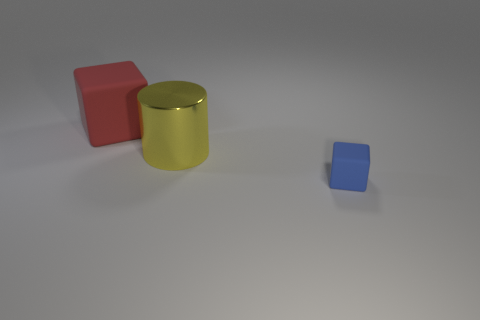What number of blue metal cylinders are there?
Make the answer very short. 0. What is the material of the large object that is on the right side of the matte cube that is behind the small matte object?
Make the answer very short. Metal. What color is the big thing in front of the block that is behind the big thing in front of the large rubber object?
Your response must be concise. Yellow. Do the big rubber cube and the metallic object have the same color?
Your answer should be very brief. No. What number of yellow things have the same size as the red matte object?
Offer a terse response. 1. Are there more metal cylinders that are in front of the small rubber cube than red matte objects behind the red matte cube?
Provide a short and direct response. No. There is a cube to the left of the matte object that is on the right side of the big matte object; what color is it?
Your response must be concise. Red. Is the material of the small blue block the same as the large cylinder?
Provide a short and direct response. No. Are there any other red matte objects of the same shape as the red matte thing?
Offer a very short reply. No. There is a big object that is in front of the large red thing; is its color the same as the large cube?
Offer a very short reply. No. 